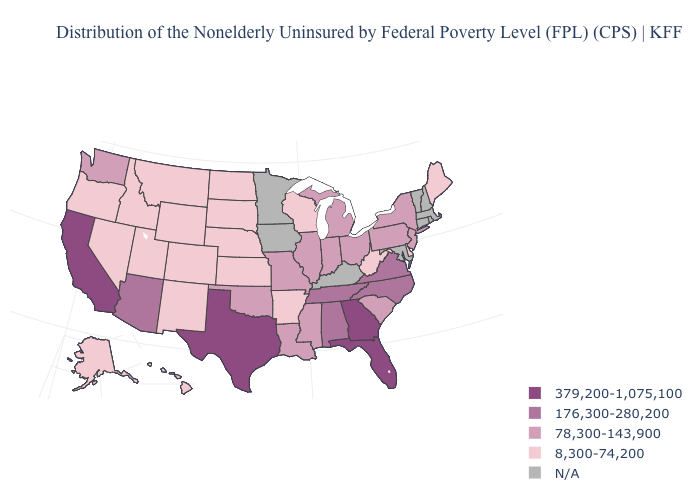Name the states that have a value in the range 8,300-74,200?
Quick response, please. Alaska, Arkansas, Colorado, Delaware, Hawaii, Idaho, Kansas, Maine, Montana, Nebraska, Nevada, New Mexico, North Dakota, Oregon, South Dakota, Utah, West Virginia, Wisconsin, Wyoming. Which states have the lowest value in the USA?
Be succinct. Alaska, Arkansas, Colorado, Delaware, Hawaii, Idaho, Kansas, Maine, Montana, Nebraska, Nevada, New Mexico, North Dakota, Oregon, South Dakota, Utah, West Virginia, Wisconsin, Wyoming. Does North Dakota have the lowest value in the MidWest?
Answer briefly. Yes. Does Georgia have the highest value in the USA?
Give a very brief answer. Yes. What is the value of Wisconsin?
Concise answer only. 8,300-74,200. Does Georgia have the highest value in the USA?
Give a very brief answer. Yes. Which states have the highest value in the USA?
Answer briefly. California, Florida, Georgia, Texas. Which states have the highest value in the USA?
Answer briefly. California, Florida, Georgia, Texas. What is the value of Alabama?
Short answer required. 176,300-280,200. What is the highest value in states that border Iowa?
Concise answer only. 78,300-143,900. What is the value of New Hampshire?
Concise answer only. N/A. Does the map have missing data?
Be succinct. Yes. 